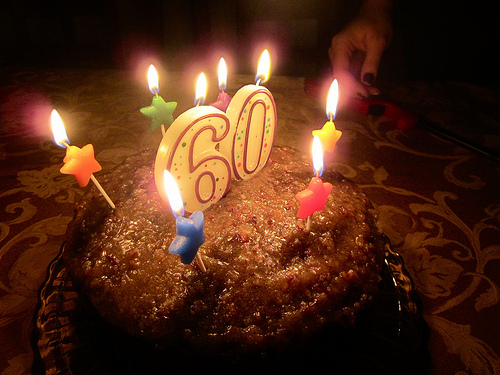<image>
Is the flame on the candle? No. The flame is not positioned on the candle. They may be near each other, but the flame is not supported by or resting on top of the candle. 